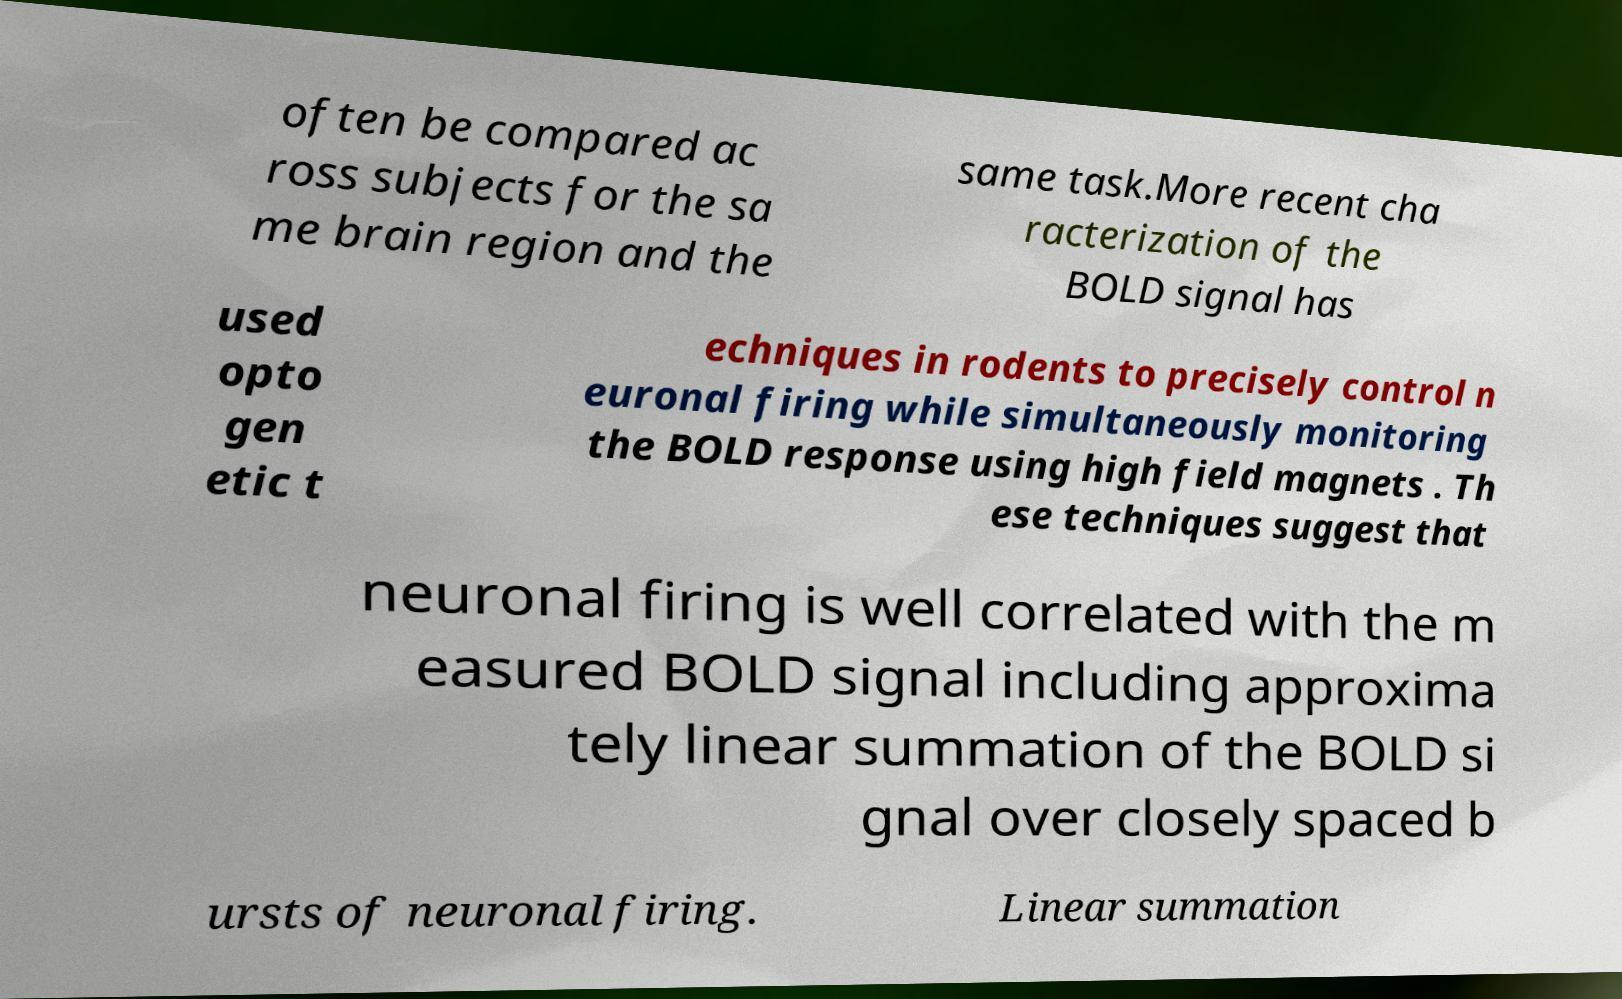Could you extract and type out the text from this image? often be compared ac ross subjects for the sa me brain region and the same task.More recent cha racterization of the BOLD signal has used opto gen etic t echniques in rodents to precisely control n euronal firing while simultaneously monitoring the BOLD response using high field magnets . Th ese techniques suggest that neuronal firing is well correlated with the m easured BOLD signal including approxima tely linear summation of the BOLD si gnal over closely spaced b ursts of neuronal firing. Linear summation 